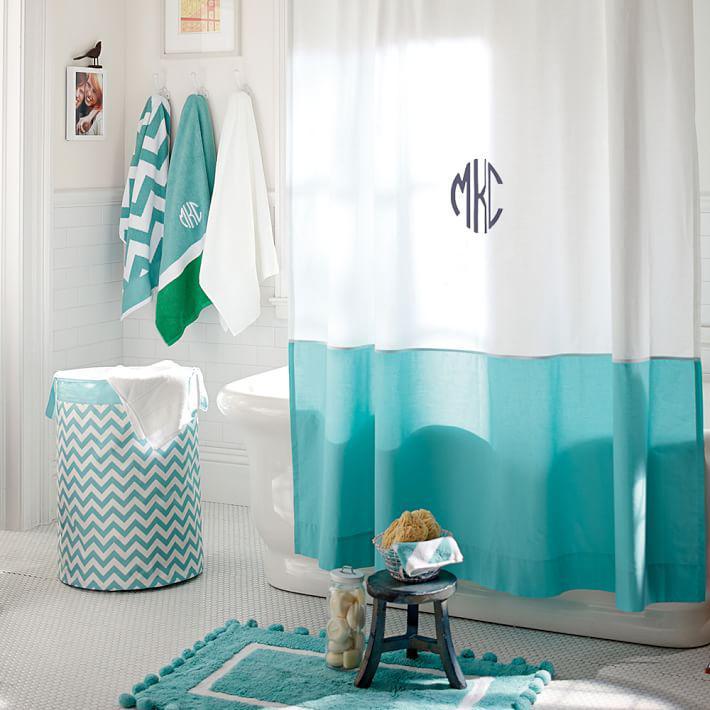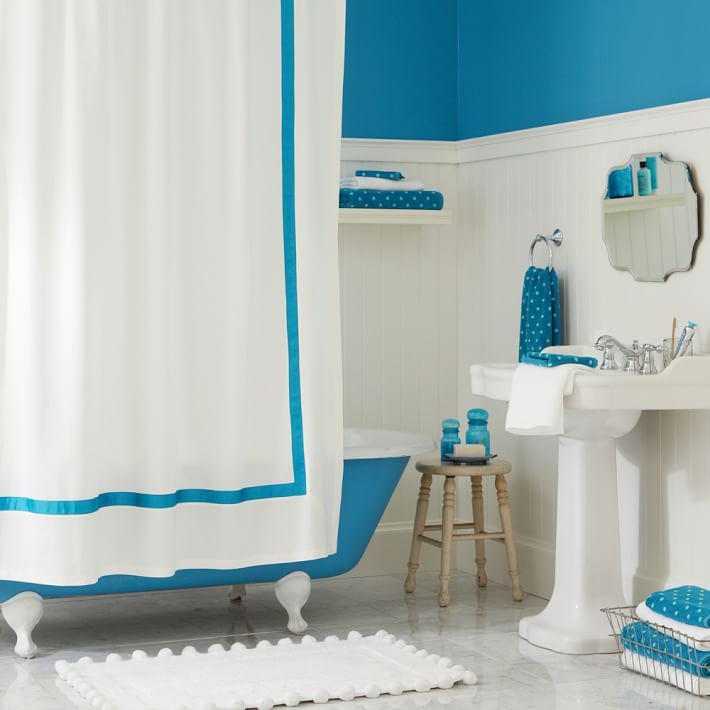The first image is the image on the left, the second image is the image on the right. For the images displayed, is the sentence "At least one bathroom has a stepstool." factually correct? Answer yes or no. Yes. The first image is the image on the left, the second image is the image on the right. For the images shown, is this caption "An image features a room with solid-white walls, and a shower curtain featuring a turquoise lower half around an all-white tub." true? Answer yes or no. Yes. 